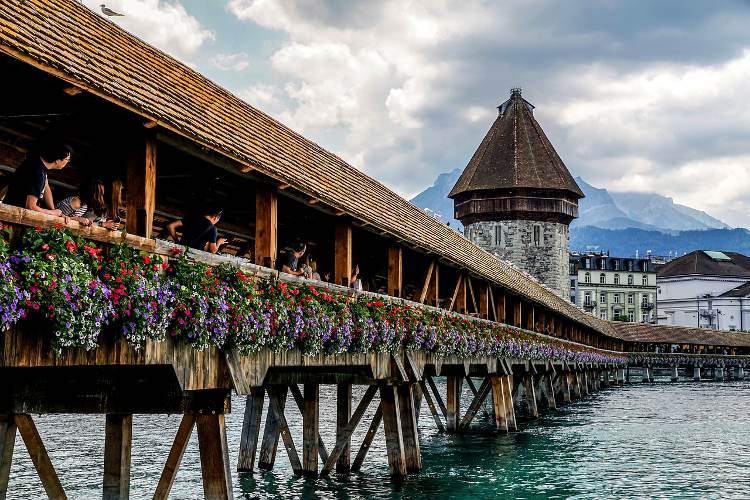Can you describe the historical significance of this bridge? The Chapel Bridge, or Kapellbrücke, in Lucerne, Switzerland, is not only a beautiful piece of architecture but also a historically significant landmark. Built in 1333, it is Europe's oldest covered wooden bridge. The bridge was constructed as part of the town's fortifications and served as a means of traversing the Reuss River while connecting the old part of Lucerne with the newer part. The Water Tower, standing next to the bridge, has served various purposes, including as a prison and a watchtower. Over the centuries, the bridge has been restored and remains a symbol of Lucerne's heritage and resilience. 